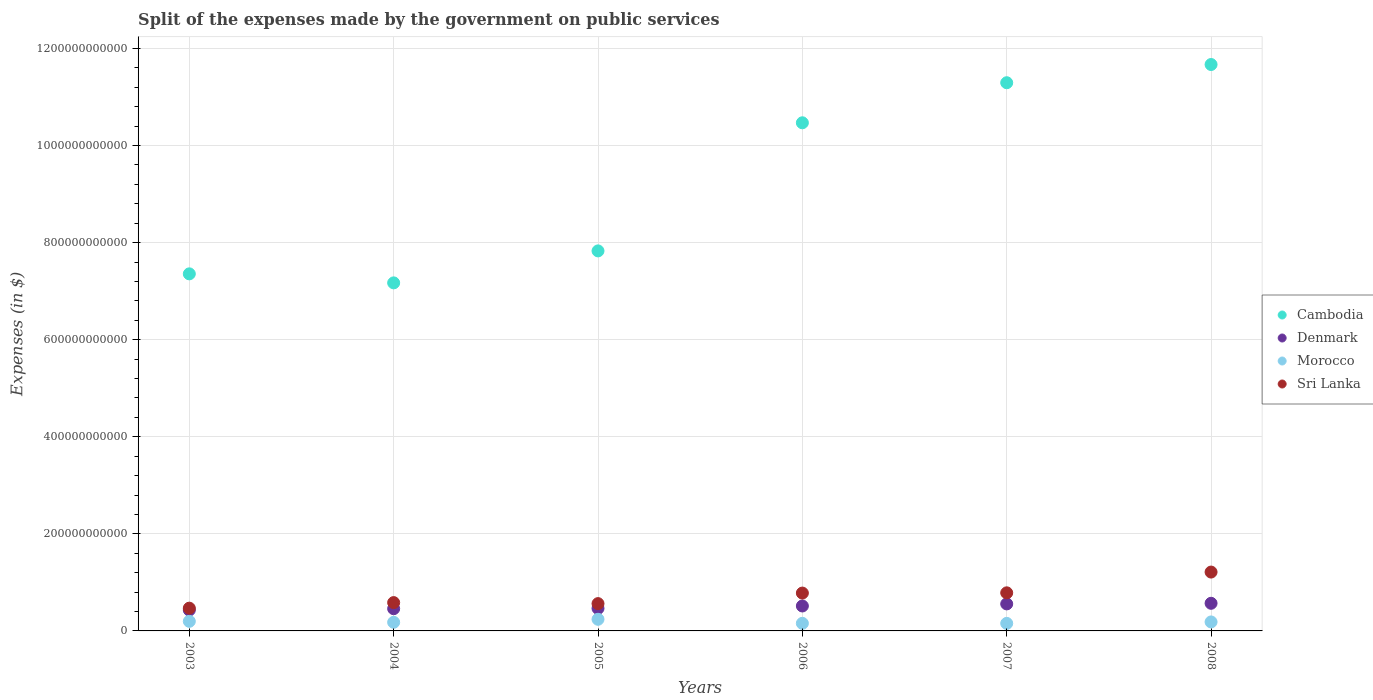Is the number of dotlines equal to the number of legend labels?
Provide a short and direct response. Yes. What is the expenses made by the government on public services in Sri Lanka in 2003?
Keep it short and to the point. 4.69e+1. Across all years, what is the maximum expenses made by the government on public services in Sri Lanka?
Provide a succinct answer. 1.21e+11. Across all years, what is the minimum expenses made by the government on public services in Denmark?
Provide a short and direct response. 4.30e+1. What is the total expenses made by the government on public services in Morocco in the graph?
Provide a succinct answer. 1.11e+11. What is the difference between the expenses made by the government on public services in Denmark in 2004 and that in 2008?
Offer a terse response. -1.12e+1. What is the difference between the expenses made by the government on public services in Denmark in 2006 and the expenses made by the government on public services in Cambodia in 2008?
Provide a succinct answer. -1.12e+12. What is the average expenses made by the government on public services in Sri Lanka per year?
Make the answer very short. 7.32e+1. In the year 2003, what is the difference between the expenses made by the government on public services in Morocco and expenses made by the government on public services in Sri Lanka?
Give a very brief answer. -2.71e+1. In how many years, is the expenses made by the government on public services in Denmark greater than 200000000000 $?
Your answer should be compact. 0. What is the ratio of the expenses made by the government on public services in Morocco in 2005 to that in 2008?
Your answer should be very brief. 1.3. What is the difference between the highest and the second highest expenses made by the government on public services in Denmark?
Offer a terse response. 1.26e+09. What is the difference between the highest and the lowest expenses made by the government on public services in Sri Lanka?
Keep it short and to the point. 7.44e+1. In how many years, is the expenses made by the government on public services in Sri Lanka greater than the average expenses made by the government on public services in Sri Lanka taken over all years?
Provide a succinct answer. 3. Is the sum of the expenses made by the government on public services in Denmark in 2006 and 2008 greater than the maximum expenses made by the government on public services in Morocco across all years?
Offer a very short reply. Yes. Does the expenses made by the government on public services in Sri Lanka monotonically increase over the years?
Offer a terse response. No. Is the expenses made by the government on public services in Morocco strictly less than the expenses made by the government on public services in Cambodia over the years?
Your answer should be compact. Yes. How many dotlines are there?
Provide a succinct answer. 4. How many years are there in the graph?
Provide a succinct answer. 6. What is the difference between two consecutive major ticks on the Y-axis?
Keep it short and to the point. 2.00e+11. Are the values on the major ticks of Y-axis written in scientific E-notation?
Offer a very short reply. No. Does the graph contain grids?
Your response must be concise. Yes. Where does the legend appear in the graph?
Provide a short and direct response. Center right. How many legend labels are there?
Your response must be concise. 4. How are the legend labels stacked?
Give a very brief answer. Vertical. What is the title of the graph?
Provide a short and direct response. Split of the expenses made by the government on public services. What is the label or title of the Y-axis?
Provide a succinct answer. Expenses (in $). What is the Expenses (in $) in Cambodia in 2003?
Keep it short and to the point. 7.36e+11. What is the Expenses (in $) of Denmark in 2003?
Provide a short and direct response. 4.30e+1. What is the Expenses (in $) of Morocco in 2003?
Your response must be concise. 1.98e+1. What is the Expenses (in $) in Sri Lanka in 2003?
Your answer should be very brief. 4.69e+1. What is the Expenses (in $) in Cambodia in 2004?
Offer a very short reply. 7.17e+11. What is the Expenses (in $) of Denmark in 2004?
Offer a very short reply. 4.58e+1. What is the Expenses (in $) in Morocco in 2004?
Offer a very short reply. 1.77e+1. What is the Expenses (in $) in Sri Lanka in 2004?
Your answer should be very brief. 5.83e+1. What is the Expenses (in $) of Cambodia in 2005?
Provide a short and direct response. 7.83e+11. What is the Expenses (in $) of Denmark in 2005?
Your response must be concise. 4.64e+1. What is the Expenses (in $) of Morocco in 2005?
Your answer should be very brief. 2.40e+1. What is the Expenses (in $) in Sri Lanka in 2005?
Offer a terse response. 5.63e+1. What is the Expenses (in $) of Cambodia in 2006?
Offer a very short reply. 1.05e+12. What is the Expenses (in $) in Denmark in 2006?
Your response must be concise. 5.14e+1. What is the Expenses (in $) in Morocco in 2006?
Keep it short and to the point. 1.56e+1. What is the Expenses (in $) of Sri Lanka in 2006?
Your answer should be compact. 7.80e+1. What is the Expenses (in $) of Cambodia in 2007?
Offer a terse response. 1.13e+12. What is the Expenses (in $) in Denmark in 2007?
Ensure brevity in your answer.  5.57e+1. What is the Expenses (in $) in Morocco in 2007?
Your response must be concise. 1.55e+1. What is the Expenses (in $) of Sri Lanka in 2007?
Your response must be concise. 7.85e+1. What is the Expenses (in $) in Cambodia in 2008?
Give a very brief answer. 1.17e+12. What is the Expenses (in $) of Denmark in 2008?
Offer a terse response. 5.69e+1. What is the Expenses (in $) in Morocco in 2008?
Provide a succinct answer. 1.85e+1. What is the Expenses (in $) of Sri Lanka in 2008?
Your answer should be very brief. 1.21e+11. Across all years, what is the maximum Expenses (in $) of Cambodia?
Your answer should be compact. 1.17e+12. Across all years, what is the maximum Expenses (in $) in Denmark?
Provide a short and direct response. 5.69e+1. Across all years, what is the maximum Expenses (in $) of Morocco?
Provide a short and direct response. 2.40e+1. Across all years, what is the maximum Expenses (in $) in Sri Lanka?
Your answer should be compact. 1.21e+11. Across all years, what is the minimum Expenses (in $) of Cambodia?
Provide a succinct answer. 7.17e+11. Across all years, what is the minimum Expenses (in $) in Denmark?
Give a very brief answer. 4.30e+1. Across all years, what is the minimum Expenses (in $) of Morocco?
Provide a succinct answer. 1.55e+1. Across all years, what is the minimum Expenses (in $) of Sri Lanka?
Provide a short and direct response. 4.69e+1. What is the total Expenses (in $) of Cambodia in the graph?
Offer a very short reply. 5.58e+12. What is the total Expenses (in $) in Denmark in the graph?
Keep it short and to the point. 2.99e+11. What is the total Expenses (in $) of Morocco in the graph?
Ensure brevity in your answer.  1.11e+11. What is the total Expenses (in $) in Sri Lanka in the graph?
Provide a succinct answer. 4.39e+11. What is the difference between the Expenses (in $) of Cambodia in 2003 and that in 2004?
Make the answer very short. 1.86e+1. What is the difference between the Expenses (in $) of Denmark in 2003 and that in 2004?
Provide a succinct answer. -2.80e+09. What is the difference between the Expenses (in $) of Morocco in 2003 and that in 2004?
Your answer should be very brief. 2.03e+09. What is the difference between the Expenses (in $) in Sri Lanka in 2003 and that in 2004?
Make the answer very short. -1.15e+1. What is the difference between the Expenses (in $) in Cambodia in 2003 and that in 2005?
Offer a terse response. -4.73e+1. What is the difference between the Expenses (in $) of Denmark in 2003 and that in 2005?
Provide a short and direct response. -3.43e+09. What is the difference between the Expenses (in $) of Morocco in 2003 and that in 2005?
Your answer should be compact. -4.20e+09. What is the difference between the Expenses (in $) in Sri Lanka in 2003 and that in 2005?
Provide a succinct answer. -9.38e+09. What is the difference between the Expenses (in $) of Cambodia in 2003 and that in 2006?
Keep it short and to the point. -3.11e+11. What is the difference between the Expenses (in $) of Denmark in 2003 and that in 2006?
Keep it short and to the point. -8.42e+09. What is the difference between the Expenses (in $) of Morocco in 2003 and that in 2006?
Ensure brevity in your answer.  4.13e+09. What is the difference between the Expenses (in $) of Sri Lanka in 2003 and that in 2006?
Your answer should be compact. -3.11e+1. What is the difference between the Expenses (in $) of Cambodia in 2003 and that in 2007?
Give a very brief answer. -3.94e+11. What is the difference between the Expenses (in $) in Denmark in 2003 and that in 2007?
Your response must be concise. -1.27e+1. What is the difference between the Expenses (in $) in Morocco in 2003 and that in 2007?
Provide a short and direct response. 4.24e+09. What is the difference between the Expenses (in $) in Sri Lanka in 2003 and that in 2007?
Your answer should be very brief. -3.16e+1. What is the difference between the Expenses (in $) of Cambodia in 2003 and that in 2008?
Ensure brevity in your answer.  -4.31e+11. What is the difference between the Expenses (in $) of Denmark in 2003 and that in 2008?
Keep it short and to the point. -1.40e+1. What is the difference between the Expenses (in $) in Morocco in 2003 and that in 2008?
Your answer should be compact. 1.27e+09. What is the difference between the Expenses (in $) in Sri Lanka in 2003 and that in 2008?
Offer a terse response. -7.44e+1. What is the difference between the Expenses (in $) in Cambodia in 2004 and that in 2005?
Your answer should be very brief. -6.59e+1. What is the difference between the Expenses (in $) in Denmark in 2004 and that in 2005?
Make the answer very short. -6.21e+08. What is the difference between the Expenses (in $) in Morocco in 2004 and that in 2005?
Your response must be concise. -6.23e+09. What is the difference between the Expenses (in $) in Sri Lanka in 2004 and that in 2005?
Your response must be concise. 2.09e+09. What is the difference between the Expenses (in $) of Cambodia in 2004 and that in 2006?
Keep it short and to the point. -3.30e+11. What is the difference between the Expenses (in $) of Denmark in 2004 and that in 2006?
Your answer should be very brief. -5.61e+09. What is the difference between the Expenses (in $) in Morocco in 2004 and that in 2006?
Your answer should be very brief. 2.10e+09. What is the difference between the Expenses (in $) of Sri Lanka in 2004 and that in 2006?
Provide a succinct answer. -1.97e+1. What is the difference between the Expenses (in $) of Cambodia in 2004 and that in 2007?
Provide a succinct answer. -4.12e+11. What is the difference between the Expenses (in $) in Denmark in 2004 and that in 2007?
Keep it short and to the point. -9.89e+09. What is the difference between the Expenses (in $) of Morocco in 2004 and that in 2007?
Provide a succinct answer. 2.21e+09. What is the difference between the Expenses (in $) in Sri Lanka in 2004 and that in 2007?
Ensure brevity in your answer.  -2.01e+1. What is the difference between the Expenses (in $) in Cambodia in 2004 and that in 2008?
Give a very brief answer. -4.50e+11. What is the difference between the Expenses (in $) of Denmark in 2004 and that in 2008?
Make the answer very short. -1.12e+1. What is the difference between the Expenses (in $) in Morocco in 2004 and that in 2008?
Make the answer very short. -7.66e+08. What is the difference between the Expenses (in $) of Sri Lanka in 2004 and that in 2008?
Offer a very short reply. -6.29e+1. What is the difference between the Expenses (in $) in Cambodia in 2005 and that in 2006?
Offer a terse response. -2.64e+11. What is the difference between the Expenses (in $) of Denmark in 2005 and that in 2006?
Offer a very short reply. -4.99e+09. What is the difference between the Expenses (in $) of Morocco in 2005 and that in 2006?
Give a very brief answer. 8.33e+09. What is the difference between the Expenses (in $) in Sri Lanka in 2005 and that in 2006?
Offer a very short reply. -2.17e+1. What is the difference between the Expenses (in $) of Cambodia in 2005 and that in 2007?
Your response must be concise. -3.46e+11. What is the difference between the Expenses (in $) in Denmark in 2005 and that in 2007?
Your response must be concise. -9.27e+09. What is the difference between the Expenses (in $) of Morocco in 2005 and that in 2007?
Provide a succinct answer. 8.44e+09. What is the difference between the Expenses (in $) in Sri Lanka in 2005 and that in 2007?
Provide a succinct answer. -2.22e+1. What is the difference between the Expenses (in $) in Cambodia in 2005 and that in 2008?
Provide a succinct answer. -3.84e+11. What is the difference between the Expenses (in $) in Denmark in 2005 and that in 2008?
Your answer should be very brief. -1.05e+1. What is the difference between the Expenses (in $) in Morocco in 2005 and that in 2008?
Give a very brief answer. 5.46e+09. What is the difference between the Expenses (in $) in Sri Lanka in 2005 and that in 2008?
Provide a short and direct response. -6.50e+1. What is the difference between the Expenses (in $) in Cambodia in 2006 and that in 2007?
Provide a succinct answer. -8.25e+1. What is the difference between the Expenses (in $) in Denmark in 2006 and that in 2007?
Offer a very short reply. -4.28e+09. What is the difference between the Expenses (in $) in Morocco in 2006 and that in 2007?
Provide a short and direct response. 1.11e+08. What is the difference between the Expenses (in $) in Sri Lanka in 2006 and that in 2007?
Your response must be concise. -4.78e+08. What is the difference between the Expenses (in $) of Cambodia in 2006 and that in 2008?
Offer a very short reply. -1.20e+11. What is the difference between the Expenses (in $) of Denmark in 2006 and that in 2008?
Provide a succinct answer. -5.54e+09. What is the difference between the Expenses (in $) in Morocco in 2006 and that in 2008?
Offer a terse response. -2.87e+09. What is the difference between the Expenses (in $) of Sri Lanka in 2006 and that in 2008?
Provide a succinct answer. -4.33e+1. What is the difference between the Expenses (in $) of Cambodia in 2007 and that in 2008?
Provide a succinct answer. -3.75e+1. What is the difference between the Expenses (in $) of Denmark in 2007 and that in 2008?
Ensure brevity in your answer.  -1.26e+09. What is the difference between the Expenses (in $) in Morocco in 2007 and that in 2008?
Give a very brief answer. -2.98e+09. What is the difference between the Expenses (in $) in Sri Lanka in 2007 and that in 2008?
Give a very brief answer. -4.28e+1. What is the difference between the Expenses (in $) in Cambodia in 2003 and the Expenses (in $) in Denmark in 2004?
Your answer should be very brief. 6.90e+11. What is the difference between the Expenses (in $) of Cambodia in 2003 and the Expenses (in $) of Morocco in 2004?
Offer a terse response. 7.18e+11. What is the difference between the Expenses (in $) of Cambodia in 2003 and the Expenses (in $) of Sri Lanka in 2004?
Give a very brief answer. 6.77e+11. What is the difference between the Expenses (in $) of Denmark in 2003 and the Expenses (in $) of Morocco in 2004?
Your answer should be very brief. 2.52e+1. What is the difference between the Expenses (in $) of Denmark in 2003 and the Expenses (in $) of Sri Lanka in 2004?
Offer a terse response. -1.54e+1. What is the difference between the Expenses (in $) in Morocco in 2003 and the Expenses (in $) in Sri Lanka in 2004?
Make the answer very short. -3.86e+1. What is the difference between the Expenses (in $) of Cambodia in 2003 and the Expenses (in $) of Denmark in 2005?
Your answer should be compact. 6.89e+11. What is the difference between the Expenses (in $) in Cambodia in 2003 and the Expenses (in $) in Morocco in 2005?
Provide a short and direct response. 7.12e+11. What is the difference between the Expenses (in $) of Cambodia in 2003 and the Expenses (in $) of Sri Lanka in 2005?
Make the answer very short. 6.79e+11. What is the difference between the Expenses (in $) of Denmark in 2003 and the Expenses (in $) of Morocco in 2005?
Offer a terse response. 1.90e+1. What is the difference between the Expenses (in $) in Denmark in 2003 and the Expenses (in $) in Sri Lanka in 2005?
Offer a terse response. -1.33e+1. What is the difference between the Expenses (in $) in Morocco in 2003 and the Expenses (in $) in Sri Lanka in 2005?
Give a very brief answer. -3.65e+1. What is the difference between the Expenses (in $) of Cambodia in 2003 and the Expenses (in $) of Denmark in 2006?
Provide a succinct answer. 6.84e+11. What is the difference between the Expenses (in $) in Cambodia in 2003 and the Expenses (in $) in Morocco in 2006?
Keep it short and to the point. 7.20e+11. What is the difference between the Expenses (in $) of Cambodia in 2003 and the Expenses (in $) of Sri Lanka in 2006?
Offer a very short reply. 6.58e+11. What is the difference between the Expenses (in $) of Denmark in 2003 and the Expenses (in $) of Morocco in 2006?
Offer a very short reply. 2.73e+1. What is the difference between the Expenses (in $) in Denmark in 2003 and the Expenses (in $) in Sri Lanka in 2006?
Provide a succinct answer. -3.50e+1. What is the difference between the Expenses (in $) in Morocco in 2003 and the Expenses (in $) in Sri Lanka in 2006?
Your answer should be compact. -5.82e+1. What is the difference between the Expenses (in $) in Cambodia in 2003 and the Expenses (in $) in Denmark in 2007?
Your response must be concise. 6.80e+11. What is the difference between the Expenses (in $) of Cambodia in 2003 and the Expenses (in $) of Morocco in 2007?
Provide a succinct answer. 7.20e+11. What is the difference between the Expenses (in $) in Cambodia in 2003 and the Expenses (in $) in Sri Lanka in 2007?
Make the answer very short. 6.57e+11. What is the difference between the Expenses (in $) of Denmark in 2003 and the Expenses (in $) of Morocco in 2007?
Your answer should be very brief. 2.74e+1. What is the difference between the Expenses (in $) in Denmark in 2003 and the Expenses (in $) in Sri Lanka in 2007?
Offer a very short reply. -3.55e+1. What is the difference between the Expenses (in $) of Morocco in 2003 and the Expenses (in $) of Sri Lanka in 2007?
Give a very brief answer. -5.87e+1. What is the difference between the Expenses (in $) of Cambodia in 2003 and the Expenses (in $) of Denmark in 2008?
Make the answer very short. 6.79e+11. What is the difference between the Expenses (in $) of Cambodia in 2003 and the Expenses (in $) of Morocco in 2008?
Provide a short and direct response. 7.17e+11. What is the difference between the Expenses (in $) in Cambodia in 2003 and the Expenses (in $) in Sri Lanka in 2008?
Offer a terse response. 6.14e+11. What is the difference between the Expenses (in $) in Denmark in 2003 and the Expenses (in $) in Morocco in 2008?
Provide a short and direct response. 2.45e+1. What is the difference between the Expenses (in $) in Denmark in 2003 and the Expenses (in $) in Sri Lanka in 2008?
Make the answer very short. -7.83e+1. What is the difference between the Expenses (in $) of Morocco in 2003 and the Expenses (in $) of Sri Lanka in 2008?
Provide a short and direct response. -1.01e+11. What is the difference between the Expenses (in $) in Cambodia in 2004 and the Expenses (in $) in Denmark in 2005?
Your response must be concise. 6.71e+11. What is the difference between the Expenses (in $) of Cambodia in 2004 and the Expenses (in $) of Morocco in 2005?
Provide a succinct answer. 6.93e+11. What is the difference between the Expenses (in $) of Cambodia in 2004 and the Expenses (in $) of Sri Lanka in 2005?
Give a very brief answer. 6.61e+11. What is the difference between the Expenses (in $) in Denmark in 2004 and the Expenses (in $) in Morocco in 2005?
Provide a succinct answer. 2.18e+1. What is the difference between the Expenses (in $) of Denmark in 2004 and the Expenses (in $) of Sri Lanka in 2005?
Your answer should be very brief. -1.05e+1. What is the difference between the Expenses (in $) of Morocco in 2004 and the Expenses (in $) of Sri Lanka in 2005?
Offer a terse response. -3.85e+1. What is the difference between the Expenses (in $) of Cambodia in 2004 and the Expenses (in $) of Denmark in 2006?
Offer a terse response. 6.66e+11. What is the difference between the Expenses (in $) of Cambodia in 2004 and the Expenses (in $) of Morocco in 2006?
Ensure brevity in your answer.  7.01e+11. What is the difference between the Expenses (in $) of Cambodia in 2004 and the Expenses (in $) of Sri Lanka in 2006?
Ensure brevity in your answer.  6.39e+11. What is the difference between the Expenses (in $) of Denmark in 2004 and the Expenses (in $) of Morocco in 2006?
Make the answer very short. 3.01e+1. What is the difference between the Expenses (in $) of Denmark in 2004 and the Expenses (in $) of Sri Lanka in 2006?
Ensure brevity in your answer.  -3.22e+1. What is the difference between the Expenses (in $) in Morocco in 2004 and the Expenses (in $) in Sri Lanka in 2006?
Keep it short and to the point. -6.03e+1. What is the difference between the Expenses (in $) in Cambodia in 2004 and the Expenses (in $) in Denmark in 2007?
Your response must be concise. 6.61e+11. What is the difference between the Expenses (in $) of Cambodia in 2004 and the Expenses (in $) of Morocco in 2007?
Give a very brief answer. 7.02e+11. What is the difference between the Expenses (in $) of Cambodia in 2004 and the Expenses (in $) of Sri Lanka in 2007?
Your answer should be compact. 6.39e+11. What is the difference between the Expenses (in $) in Denmark in 2004 and the Expenses (in $) in Morocco in 2007?
Provide a succinct answer. 3.02e+1. What is the difference between the Expenses (in $) in Denmark in 2004 and the Expenses (in $) in Sri Lanka in 2007?
Provide a short and direct response. -3.27e+1. What is the difference between the Expenses (in $) of Morocco in 2004 and the Expenses (in $) of Sri Lanka in 2007?
Provide a succinct answer. -6.07e+1. What is the difference between the Expenses (in $) in Cambodia in 2004 and the Expenses (in $) in Denmark in 2008?
Make the answer very short. 6.60e+11. What is the difference between the Expenses (in $) of Cambodia in 2004 and the Expenses (in $) of Morocco in 2008?
Provide a succinct answer. 6.99e+11. What is the difference between the Expenses (in $) in Cambodia in 2004 and the Expenses (in $) in Sri Lanka in 2008?
Your answer should be very brief. 5.96e+11. What is the difference between the Expenses (in $) in Denmark in 2004 and the Expenses (in $) in Morocco in 2008?
Your answer should be compact. 2.73e+1. What is the difference between the Expenses (in $) of Denmark in 2004 and the Expenses (in $) of Sri Lanka in 2008?
Offer a terse response. -7.55e+1. What is the difference between the Expenses (in $) in Morocco in 2004 and the Expenses (in $) in Sri Lanka in 2008?
Make the answer very short. -1.04e+11. What is the difference between the Expenses (in $) of Cambodia in 2005 and the Expenses (in $) of Denmark in 2006?
Ensure brevity in your answer.  7.32e+11. What is the difference between the Expenses (in $) in Cambodia in 2005 and the Expenses (in $) in Morocco in 2006?
Give a very brief answer. 7.67e+11. What is the difference between the Expenses (in $) of Cambodia in 2005 and the Expenses (in $) of Sri Lanka in 2006?
Give a very brief answer. 7.05e+11. What is the difference between the Expenses (in $) in Denmark in 2005 and the Expenses (in $) in Morocco in 2006?
Your answer should be compact. 3.07e+1. What is the difference between the Expenses (in $) of Denmark in 2005 and the Expenses (in $) of Sri Lanka in 2006?
Keep it short and to the point. -3.16e+1. What is the difference between the Expenses (in $) in Morocco in 2005 and the Expenses (in $) in Sri Lanka in 2006?
Provide a short and direct response. -5.40e+1. What is the difference between the Expenses (in $) in Cambodia in 2005 and the Expenses (in $) in Denmark in 2007?
Offer a very short reply. 7.27e+11. What is the difference between the Expenses (in $) of Cambodia in 2005 and the Expenses (in $) of Morocco in 2007?
Provide a short and direct response. 7.67e+11. What is the difference between the Expenses (in $) in Cambodia in 2005 and the Expenses (in $) in Sri Lanka in 2007?
Make the answer very short. 7.04e+11. What is the difference between the Expenses (in $) in Denmark in 2005 and the Expenses (in $) in Morocco in 2007?
Your answer should be compact. 3.09e+1. What is the difference between the Expenses (in $) of Denmark in 2005 and the Expenses (in $) of Sri Lanka in 2007?
Make the answer very short. -3.21e+1. What is the difference between the Expenses (in $) of Morocco in 2005 and the Expenses (in $) of Sri Lanka in 2007?
Offer a very short reply. -5.45e+1. What is the difference between the Expenses (in $) of Cambodia in 2005 and the Expenses (in $) of Denmark in 2008?
Keep it short and to the point. 7.26e+11. What is the difference between the Expenses (in $) of Cambodia in 2005 and the Expenses (in $) of Morocco in 2008?
Provide a succinct answer. 7.64e+11. What is the difference between the Expenses (in $) in Cambodia in 2005 and the Expenses (in $) in Sri Lanka in 2008?
Make the answer very short. 6.62e+11. What is the difference between the Expenses (in $) of Denmark in 2005 and the Expenses (in $) of Morocco in 2008?
Offer a terse response. 2.79e+1. What is the difference between the Expenses (in $) in Denmark in 2005 and the Expenses (in $) in Sri Lanka in 2008?
Offer a very short reply. -7.49e+1. What is the difference between the Expenses (in $) in Morocco in 2005 and the Expenses (in $) in Sri Lanka in 2008?
Your answer should be very brief. -9.73e+1. What is the difference between the Expenses (in $) in Cambodia in 2006 and the Expenses (in $) in Denmark in 2007?
Ensure brevity in your answer.  9.91e+11. What is the difference between the Expenses (in $) of Cambodia in 2006 and the Expenses (in $) of Morocco in 2007?
Provide a short and direct response. 1.03e+12. What is the difference between the Expenses (in $) in Cambodia in 2006 and the Expenses (in $) in Sri Lanka in 2007?
Ensure brevity in your answer.  9.68e+11. What is the difference between the Expenses (in $) of Denmark in 2006 and the Expenses (in $) of Morocco in 2007?
Your answer should be very brief. 3.59e+1. What is the difference between the Expenses (in $) in Denmark in 2006 and the Expenses (in $) in Sri Lanka in 2007?
Give a very brief answer. -2.71e+1. What is the difference between the Expenses (in $) of Morocco in 2006 and the Expenses (in $) of Sri Lanka in 2007?
Your answer should be compact. -6.28e+1. What is the difference between the Expenses (in $) in Cambodia in 2006 and the Expenses (in $) in Denmark in 2008?
Give a very brief answer. 9.90e+11. What is the difference between the Expenses (in $) in Cambodia in 2006 and the Expenses (in $) in Morocco in 2008?
Offer a very short reply. 1.03e+12. What is the difference between the Expenses (in $) of Cambodia in 2006 and the Expenses (in $) of Sri Lanka in 2008?
Give a very brief answer. 9.26e+11. What is the difference between the Expenses (in $) of Denmark in 2006 and the Expenses (in $) of Morocco in 2008?
Provide a succinct answer. 3.29e+1. What is the difference between the Expenses (in $) of Denmark in 2006 and the Expenses (in $) of Sri Lanka in 2008?
Provide a short and direct response. -6.99e+1. What is the difference between the Expenses (in $) in Morocco in 2006 and the Expenses (in $) in Sri Lanka in 2008?
Offer a very short reply. -1.06e+11. What is the difference between the Expenses (in $) in Cambodia in 2007 and the Expenses (in $) in Denmark in 2008?
Provide a succinct answer. 1.07e+12. What is the difference between the Expenses (in $) in Cambodia in 2007 and the Expenses (in $) in Morocco in 2008?
Your response must be concise. 1.11e+12. What is the difference between the Expenses (in $) in Cambodia in 2007 and the Expenses (in $) in Sri Lanka in 2008?
Offer a terse response. 1.01e+12. What is the difference between the Expenses (in $) of Denmark in 2007 and the Expenses (in $) of Morocco in 2008?
Your response must be concise. 3.72e+1. What is the difference between the Expenses (in $) of Denmark in 2007 and the Expenses (in $) of Sri Lanka in 2008?
Provide a succinct answer. -6.56e+1. What is the difference between the Expenses (in $) in Morocco in 2007 and the Expenses (in $) in Sri Lanka in 2008?
Make the answer very short. -1.06e+11. What is the average Expenses (in $) of Cambodia per year?
Provide a succinct answer. 9.30e+11. What is the average Expenses (in $) in Denmark per year?
Ensure brevity in your answer.  4.98e+1. What is the average Expenses (in $) of Morocco per year?
Provide a succinct answer. 1.85e+1. What is the average Expenses (in $) in Sri Lanka per year?
Make the answer very short. 7.32e+1. In the year 2003, what is the difference between the Expenses (in $) in Cambodia and Expenses (in $) in Denmark?
Provide a succinct answer. 6.93e+11. In the year 2003, what is the difference between the Expenses (in $) in Cambodia and Expenses (in $) in Morocco?
Your answer should be very brief. 7.16e+11. In the year 2003, what is the difference between the Expenses (in $) in Cambodia and Expenses (in $) in Sri Lanka?
Your answer should be very brief. 6.89e+11. In the year 2003, what is the difference between the Expenses (in $) in Denmark and Expenses (in $) in Morocco?
Ensure brevity in your answer.  2.32e+1. In the year 2003, what is the difference between the Expenses (in $) of Denmark and Expenses (in $) of Sri Lanka?
Offer a very short reply. -3.92e+09. In the year 2003, what is the difference between the Expenses (in $) of Morocco and Expenses (in $) of Sri Lanka?
Make the answer very short. -2.71e+1. In the year 2004, what is the difference between the Expenses (in $) of Cambodia and Expenses (in $) of Denmark?
Your answer should be compact. 6.71e+11. In the year 2004, what is the difference between the Expenses (in $) of Cambodia and Expenses (in $) of Morocco?
Your answer should be compact. 6.99e+11. In the year 2004, what is the difference between the Expenses (in $) in Cambodia and Expenses (in $) in Sri Lanka?
Your answer should be very brief. 6.59e+11. In the year 2004, what is the difference between the Expenses (in $) of Denmark and Expenses (in $) of Morocco?
Ensure brevity in your answer.  2.80e+1. In the year 2004, what is the difference between the Expenses (in $) of Denmark and Expenses (in $) of Sri Lanka?
Your answer should be compact. -1.26e+1. In the year 2004, what is the difference between the Expenses (in $) in Morocco and Expenses (in $) in Sri Lanka?
Your response must be concise. -4.06e+1. In the year 2005, what is the difference between the Expenses (in $) of Cambodia and Expenses (in $) of Denmark?
Provide a succinct answer. 7.37e+11. In the year 2005, what is the difference between the Expenses (in $) of Cambodia and Expenses (in $) of Morocco?
Ensure brevity in your answer.  7.59e+11. In the year 2005, what is the difference between the Expenses (in $) of Cambodia and Expenses (in $) of Sri Lanka?
Your answer should be compact. 7.27e+11. In the year 2005, what is the difference between the Expenses (in $) of Denmark and Expenses (in $) of Morocco?
Offer a very short reply. 2.24e+1. In the year 2005, what is the difference between the Expenses (in $) in Denmark and Expenses (in $) in Sri Lanka?
Your response must be concise. -9.87e+09. In the year 2005, what is the difference between the Expenses (in $) in Morocco and Expenses (in $) in Sri Lanka?
Make the answer very short. -3.23e+1. In the year 2006, what is the difference between the Expenses (in $) of Cambodia and Expenses (in $) of Denmark?
Ensure brevity in your answer.  9.95e+11. In the year 2006, what is the difference between the Expenses (in $) of Cambodia and Expenses (in $) of Morocco?
Make the answer very short. 1.03e+12. In the year 2006, what is the difference between the Expenses (in $) in Cambodia and Expenses (in $) in Sri Lanka?
Give a very brief answer. 9.69e+11. In the year 2006, what is the difference between the Expenses (in $) in Denmark and Expenses (in $) in Morocco?
Ensure brevity in your answer.  3.57e+1. In the year 2006, what is the difference between the Expenses (in $) in Denmark and Expenses (in $) in Sri Lanka?
Ensure brevity in your answer.  -2.66e+1. In the year 2006, what is the difference between the Expenses (in $) in Morocco and Expenses (in $) in Sri Lanka?
Provide a short and direct response. -6.24e+1. In the year 2007, what is the difference between the Expenses (in $) of Cambodia and Expenses (in $) of Denmark?
Your response must be concise. 1.07e+12. In the year 2007, what is the difference between the Expenses (in $) in Cambodia and Expenses (in $) in Morocco?
Your response must be concise. 1.11e+12. In the year 2007, what is the difference between the Expenses (in $) in Cambodia and Expenses (in $) in Sri Lanka?
Your answer should be very brief. 1.05e+12. In the year 2007, what is the difference between the Expenses (in $) of Denmark and Expenses (in $) of Morocco?
Keep it short and to the point. 4.01e+1. In the year 2007, what is the difference between the Expenses (in $) of Denmark and Expenses (in $) of Sri Lanka?
Your response must be concise. -2.28e+1. In the year 2007, what is the difference between the Expenses (in $) of Morocco and Expenses (in $) of Sri Lanka?
Provide a short and direct response. -6.29e+1. In the year 2008, what is the difference between the Expenses (in $) in Cambodia and Expenses (in $) in Denmark?
Give a very brief answer. 1.11e+12. In the year 2008, what is the difference between the Expenses (in $) in Cambodia and Expenses (in $) in Morocco?
Provide a succinct answer. 1.15e+12. In the year 2008, what is the difference between the Expenses (in $) of Cambodia and Expenses (in $) of Sri Lanka?
Your answer should be very brief. 1.05e+12. In the year 2008, what is the difference between the Expenses (in $) in Denmark and Expenses (in $) in Morocco?
Give a very brief answer. 3.84e+1. In the year 2008, what is the difference between the Expenses (in $) of Denmark and Expenses (in $) of Sri Lanka?
Give a very brief answer. -6.43e+1. In the year 2008, what is the difference between the Expenses (in $) of Morocco and Expenses (in $) of Sri Lanka?
Give a very brief answer. -1.03e+11. What is the ratio of the Expenses (in $) of Cambodia in 2003 to that in 2004?
Your answer should be very brief. 1.03. What is the ratio of the Expenses (in $) of Denmark in 2003 to that in 2004?
Make the answer very short. 0.94. What is the ratio of the Expenses (in $) of Morocco in 2003 to that in 2004?
Offer a very short reply. 1.11. What is the ratio of the Expenses (in $) of Sri Lanka in 2003 to that in 2004?
Give a very brief answer. 0.8. What is the ratio of the Expenses (in $) in Cambodia in 2003 to that in 2005?
Offer a very short reply. 0.94. What is the ratio of the Expenses (in $) in Denmark in 2003 to that in 2005?
Your response must be concise. 0.93. What is the ratio of the Expenses (in $) of Morocco in 2003 to that in 2005?
Provide a short and direct response. 0.82. What is the ratio of the Expenses (in $) of Sri Lanka in 2003 to that in 2005?
Your response must be concise. 0.83. What is the ratio of the Expenses (in $) of Cambodia in 2003 to that in 2006?
Give a very brief answer. 0.7. What is the ratio of the Expenses (in $) in Denmark in 2003 to that in 2006?
Offer a very short reply. 0.84. What is the ratio of the Expenses (in $) of Morocco in 2003 to that in 2006?
Your answer should be very brief. 1.26. What is the ratio of the Expenses (in $) in Sri Lanka in 2003 to that in 2006?
Ensure brevity in your answer.  0.6. What is the ratio of the Expenses (in $) in Cambodia in 2003 to that in 2007?
Ensure brevity in your answer.  0.65. What is the ratio of the Expenses (in $) in Denmark in 2003 to that in 2007?
Offer a very short reply. 0.77. What is the ratio of the Expenses (in $) in Morocco in 2003 to that in 2007?
Ensure brevity in your answer.  1.27. What is the ratio of the Expenses (in $) of Sri Lanka in 2003 to that in 2007?
Your response must be concise. 0.6. What is the ratio of the Expenses (in $) in Cambodia in 2003 to that in 2008?
Give a very brief answer. 0.63. What is the ratio of the Expenses (in $) of Denmark in 2003 to that in 2008?
Ensure brevity in your answer.  0.75. What is the ratio of the Expenses (in $) of Morocco in 2003 to that in 2008?
Ensure brevity in your answer.  1.07. What is the ratio of the Expenses (in $) of Sri Lanka in 2003 to that in 2008?
Keep it short and to the point. 0.39. What is the ratio of the Expenses (in $) of Cambodia in 2004 to that in 2005?
Your response must be concise. 0.92. What is the ratio of the Expenses (in $) of Denmark in 2004 to that in 2005?
Offer a terse response. 0.99. What is the ratio of the Expenses (in $) of Morocco in 2004 to that in 2005?
Your answer should be compact. 0.74. What is the ratio of the Expenses (in $) in Sri Lanka in 2004 to that in 2005?
Keep it short and to the point. 1.04. What is the ratio of the Expenses (in $) in Cambodia in 2004 to that in 2006?
Make the answer very short. 0.69. What is the ratio of the Expenses (in $) of Denmark in 2004 to that in 2006?
Your response must be concise. 0.89. What is the ratio of the Expenses (in $) of Morocco in 2004 to that in 2006?
Ensure brevity in your answer.  1.13. What is the ratio of the Expenses (in $) in Sri Lanka in 2004 to that in 2006?
Offer a terse response. 0.75. What is the ratio of the Expenses (in $) of Cambodia in 2004 to that in 2007?
Ensure brevity in your answer.  0.63. What is the ratio of the Expenses (in $) of Denmark in 2004 to that in 2007?
Ensure brevity in your answer.  0.82. What is the ratio of the Expenses (in $) of Morocco in 2004 to that in 2007?
Your answer should be compact. 1.14. What is the ratio of the Expenses (in $) of Sri Lanka in 2004 to that in 2007?
Make the answer very short. 0.74. What is the ratio of the Expenses (in $) in Cambodia in 2004 to that in 2008?
Offer a terse response. 0.61. What is the ratio of the Expenses (in $) in Denmark in 2004 to that in 2008?
Your answer should be very brief. 0.8. What is the ratio of the Expenses (in $) of Morocco in 2004 to that in 2008?
Offer a very short reply. 0.96. What is the ratio of the Expenses (in $) in Sri Lanka in 2004 to that in 2008?
Ensure brevity in your answer.  0.48. What is the ratio of the Expenses (in $) in Cambodia in 2005 to that in 2006?
Make the answer very short. 0.75. What is the ratio of the Expenses (in $) in Denmark in 2005 to that in 2006?
Keep it short and to the point. 0.9. What is the ratio of the Expenses (in $) in Morocco in 2005 to that in 2006?
Make the answer very short. 1.53. What is the ratio of the Expenses (in $) of Sri Lanka in 2005 to that in 2006?
Your answer should be compact. 0.72. What is the ratio of the Expenses (in $) in Cambodia in 2005 to that in 2007?
Give a very brief answer. 0.69. What is the ratio of the Expenses (in $) in Denmark in 2005 to that in 2007?
Offer a terse response. 0.83. What is the ratio of the Expenses (in $) of Morocco in 2005 to that in 2007?
Offer a terse response. 1.54. What is the ratio of the Expenses (in $) of Sri Lanka in 2005 to that in 2007?
Ensure brevity in your answer.  0.72. What is the ratio of the Expenses (in $) in Cambodia in 2005 to that in 2008?
Offer a very short reply. 0.67. What is the ratio of the Expenses (in $) in Denmark in 2005 to that in 2008?
Make the answer very short. 0.81. What is the ratio of the Expenses (in $) in Morocco in 2005 to that in 2008?
Offer a terse response. 1.3. What is the ratio of the Expenses (in $) of Sri Lanka in 2005 to that in 2008?
Ensure brevity in your answer.  0.46. What is the ratio of the Expenses (in $) of Cambodia in 2006 to that in 2007?
Provide a short and direct response. 0.93. What is the ratio of the Expenses (in $) in Denmark in 2006 to that in 2007?
Your answer should be compact. 0.92. What is the ratio of the Expenses (in $) in Morocco in 2006 to that in 2007?
Give a very brief answer. 1.01. What is the ratio of the Expenses (in $) in Cambodia in 2006 to that in 2008?
Your answer should be compact. 0.9. What is the ratio of the Expenses (in $) in Denmark in 2006 to that in 2008?
Keep it short and to the point. 0.9. What is the ratio of the Expenses (in $) in Morocco in 2006 to that in 2008?
Your response must be concise. 0.84. What is the ratio of the Expenses (in $) of Sri Lanka in 2006 to that in 2008?
Your answer should be compact. 0.64. What is the ratio of the Expenses (in $) in Cambodia in 2007 to that in 2008?
Provide a succinct answer. 0.97. What is the ratio of the Expenses (in $) in Denmark in 2007 to that in 2008?
Your answer should be compact. 0.98. What is the ratio of the Expenses (in $) in Morocco in 2007 to that in 2008?
Make the answer very short. 0.84. What is the ratio of the Expenses (in $) in Sri Lanka in 2007 to that in 2008?
Your response must be concise. 0.65. What is the difference between the highest and the second highest Expenses (in $) of Cambodia?
Offer a very short reply. 3.75e+1. What is the difference between the highest and the second highest Expenses (in $) of Denmark?
Provide a short and direct response. 1.26e+09. What is the difference between the highest and the second highest Expenses (in $) in Morocco?
Your answer should be very brief. 4.20e+09. What is the difference between the highest and the second highest Expenses (in $) in Sri Lanka?
Give a very brief answer. 4.28e+1. What is the difference between the highest and the lowest Expenses (in $) in Cambodia?
Make the answer very short. 4.50e+11. What is the difference between the highest and the lowest Expenses (in $) in Denmark?
Ensure brevity in your answer.  1.40e+1. What is the difference between the highest and the lowest Expenses (in $) of Morocco?
Provide a succinct answer. 8.44e+09. What is the difference between the highest and the lowest Expenses (in $) in Sri Lanka?
Ensure brevity in your answer.  7.44e+1. 